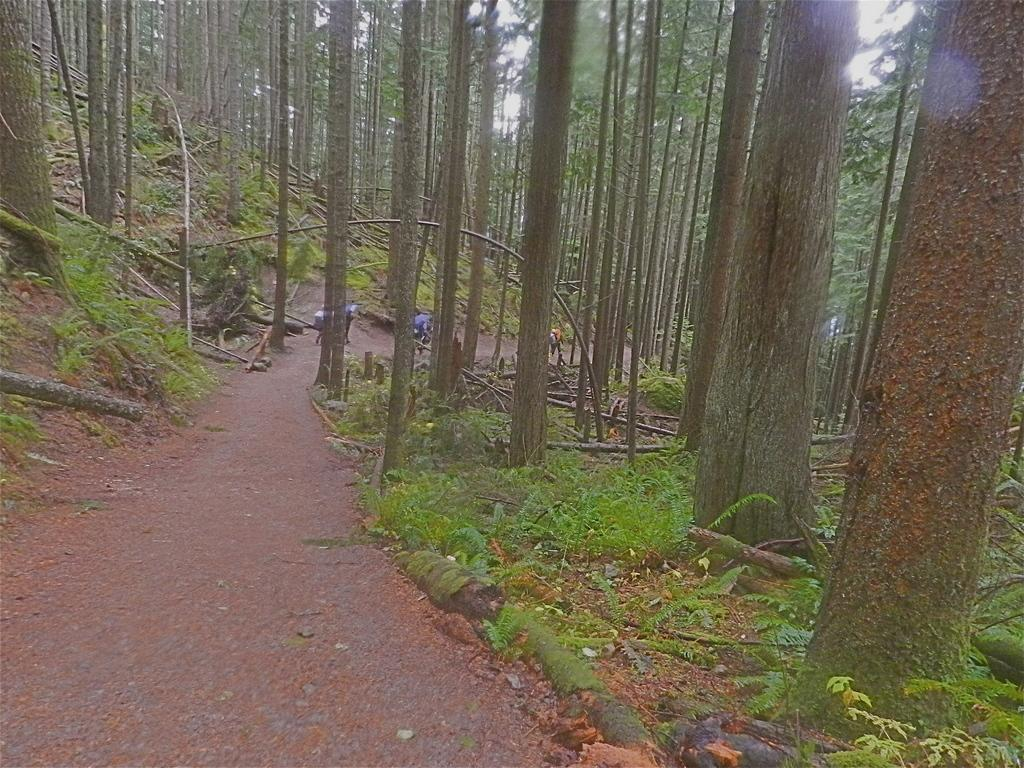What can be seen in the image? There are persons standing in the image. What type of natural elements are present in the image? There are trees and plants in the image. What is visible in the background of the image? The sky is visible in the background of the image. What type of street can be seen in the image? There is no street present in the image; it features persons standing, trees, plants, and the sky. 